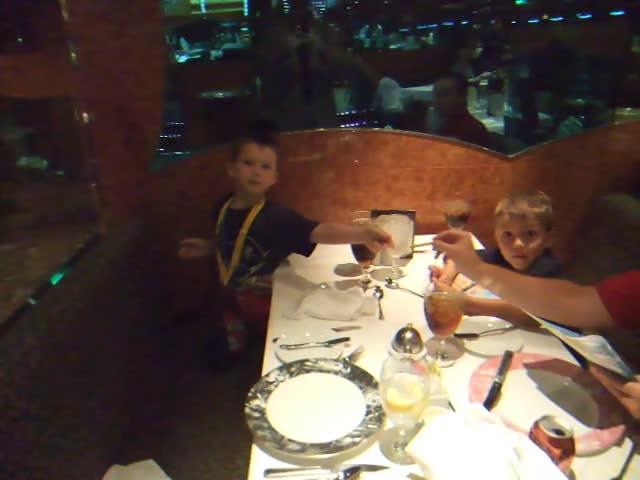What color is the lanyard string worn around the little boy's neck? yellow 